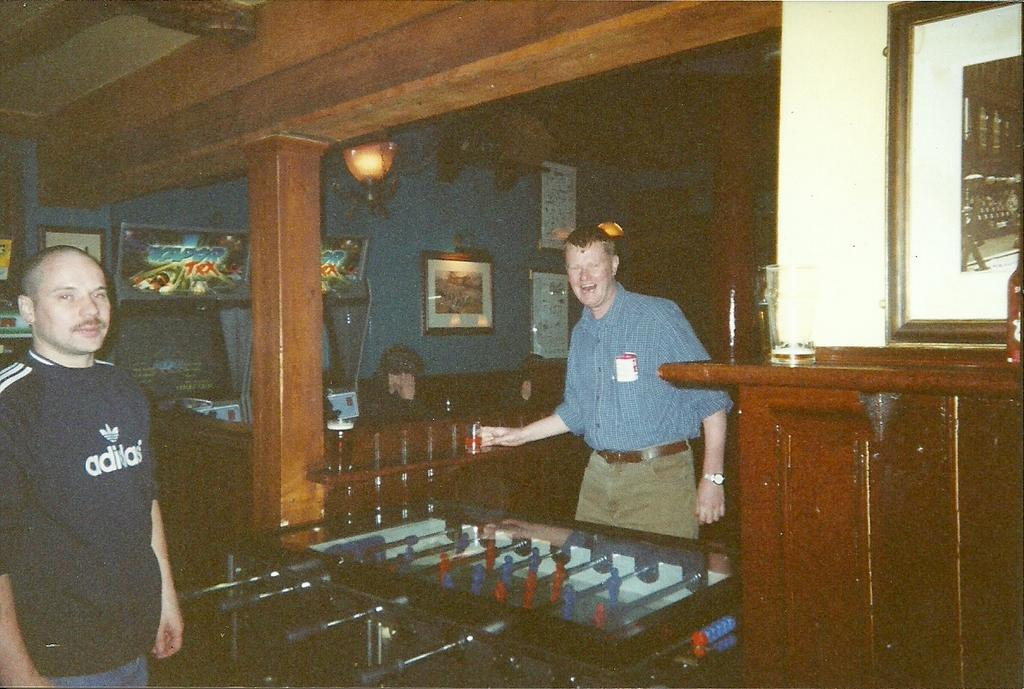How many people are present in the image? There are two people standing in the image. Can you describe the clothing of one of the individuals? One person is wearing a blue color shirt. What accessory is the person in the blue shirt wearing? The person in the blue shirt is wearing a watch. What can be seen in the background of the image? There is a cupboard, a pillar, and photo albums on lights in the background of the image. What type of lace is draped over the pillar in the image? There is no lace draped over the pillar in the image; it is a solid structure. How many boys are present in the image? The image does not specify the gender of the individuals, so it cannot be determined if there are any boys present. 